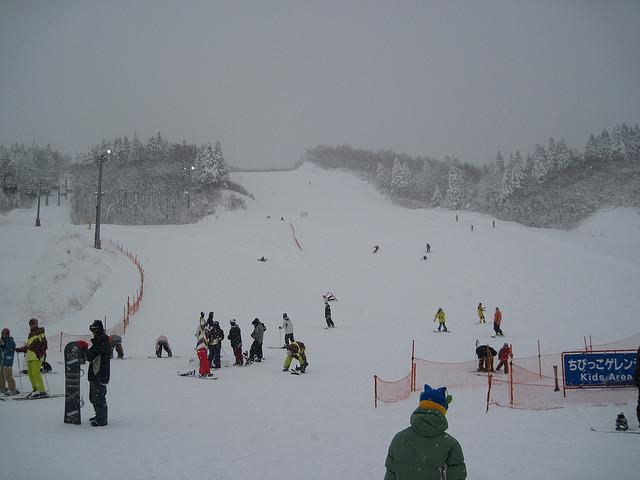Why is this hill so small?

Choices:
A) for practice
B) buried snow
C) nothing else
D) for children for children 